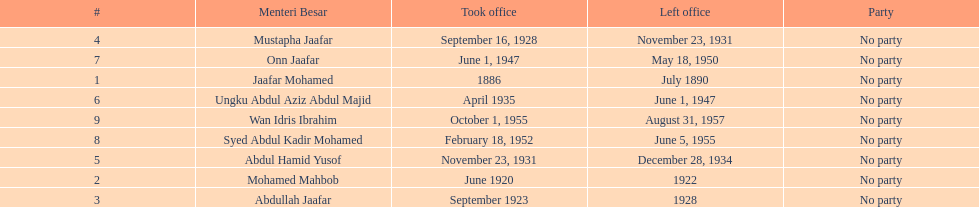What are all the people that were menteri besar of johor? Jaafar Mohamed, Mohamed Mahbob, Abdullah Jaafar, Mustapha Jaafar, Abdul Hamid Yusof, Ungku Abdul Aziz Abdul Majid, Onn Jaafar, Syed Abdul Kadir Mohamed, Wan Idris Ibrahim. Who ruled the longest? Ungku Abdul Aziz Abdul Majid. 